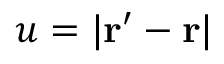Convert formula to latex. <formula><loc_0><loc_0><loc_500><loc_500>u = | { r } ^ { \prime } - { r } |</formula> 